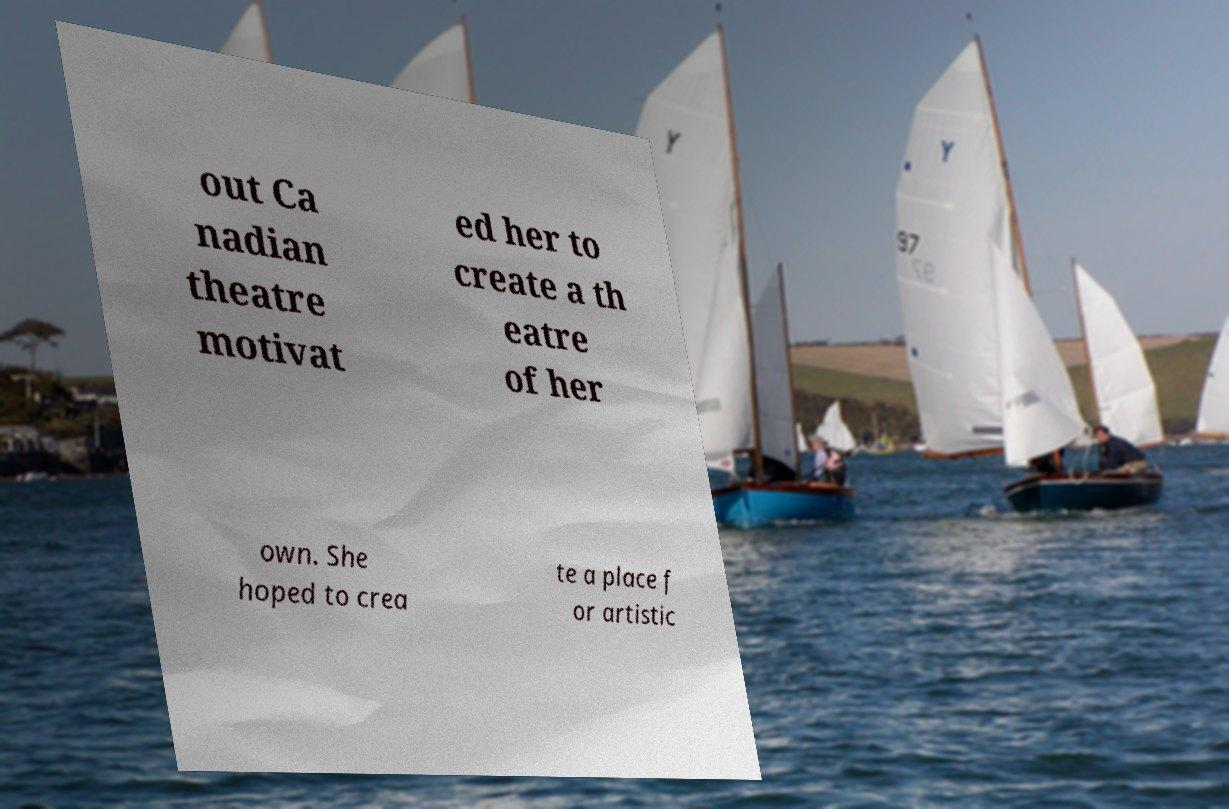I need the written content from this picture converted into text. Can you do that? out Ca nadian theatre motivat ed her to create a th eatre of her own. She hoped to crea te a place f or artistic 